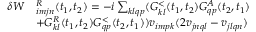Convert formula to latex. <formula><loc_0><loc_0><loc_500><loc_500>\begin{array} { r l } { \delta W } & { ^ { R } _ { i m j n } ( t _ { 1 } , t _ { 2 } ) = - i \sum _ { k l q p } ( G _ { k l } ^ { < } ( t _ { 1 } , t _ { 2 } ) G _ { q p } ^ { A } ( t _ { 2 } , t _ { 1 } ) } \\ & { + G _ { k l } ^ { R } ( t _ { 1 } , t _ { 2 } ) G _ { q p } ^ { < } ( t _ { 2 } , t _ { 1 } ) ) v _ { i m p k } ( 2 v _ { j n q l } - v _ { j l q n } ) } \end{array}</formula> 